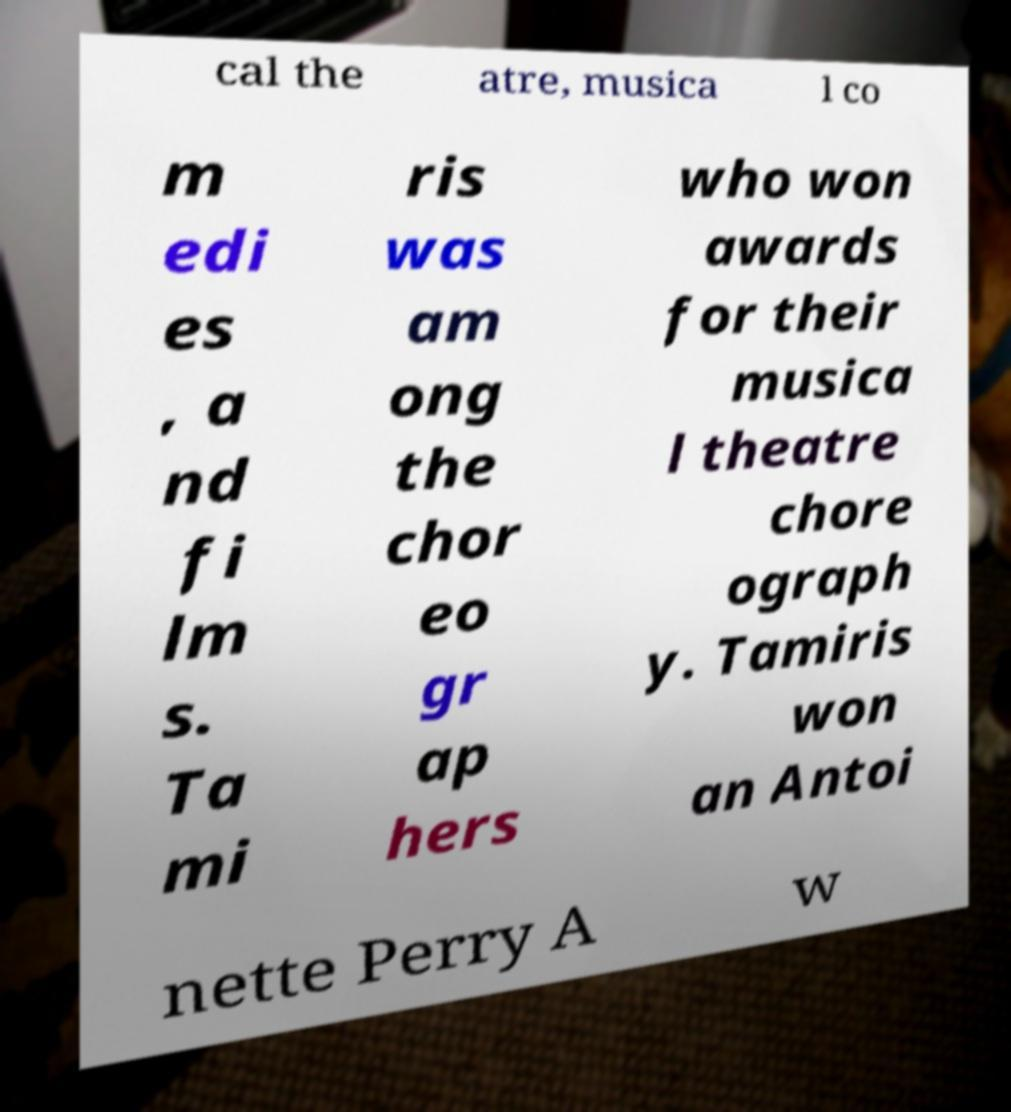Can you read and provide the text displayed in the image?This photo seems to have some interesting text. Can you extract and type it out for me? cal the atre, musica l co m edi es , a nd fi lm s. Ta mi ris was am ong the chor eo gr ap hers who won awards for their musica l theatre chore ograph y. Tamiris won an Antoi nette Perry A w 